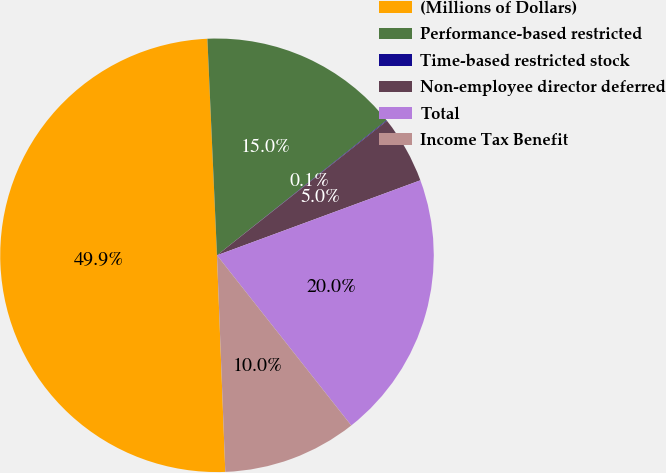<chart> <loc_0><loc_0><loc_500><loc_500><pie_chart><fcel>(Millions of Dollars)<fcel>Performance-based restricted<fcel>Time-based restricted stock<fcel>Non-employee director deferred<fcel>Total<fcel>Income Tax Benefit<nl><fcel>49.9%<fcel>15.0%<fcel>0.05%<fcel>5.03%<fcel>19.99%<fcel>10.02%<nl></chart> 